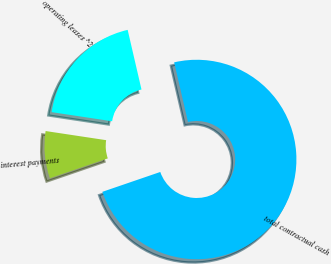Convert chart to OTSL. <chart><loc_0><loc_0><loc_500><loc_500><pie_chart><fcel>interest payments<fcel>operating leases ^2<fcel>total contractual cash<nl><fcel>7.64%<fcel>18.99%<fcel>73.37%<nl></chart> 